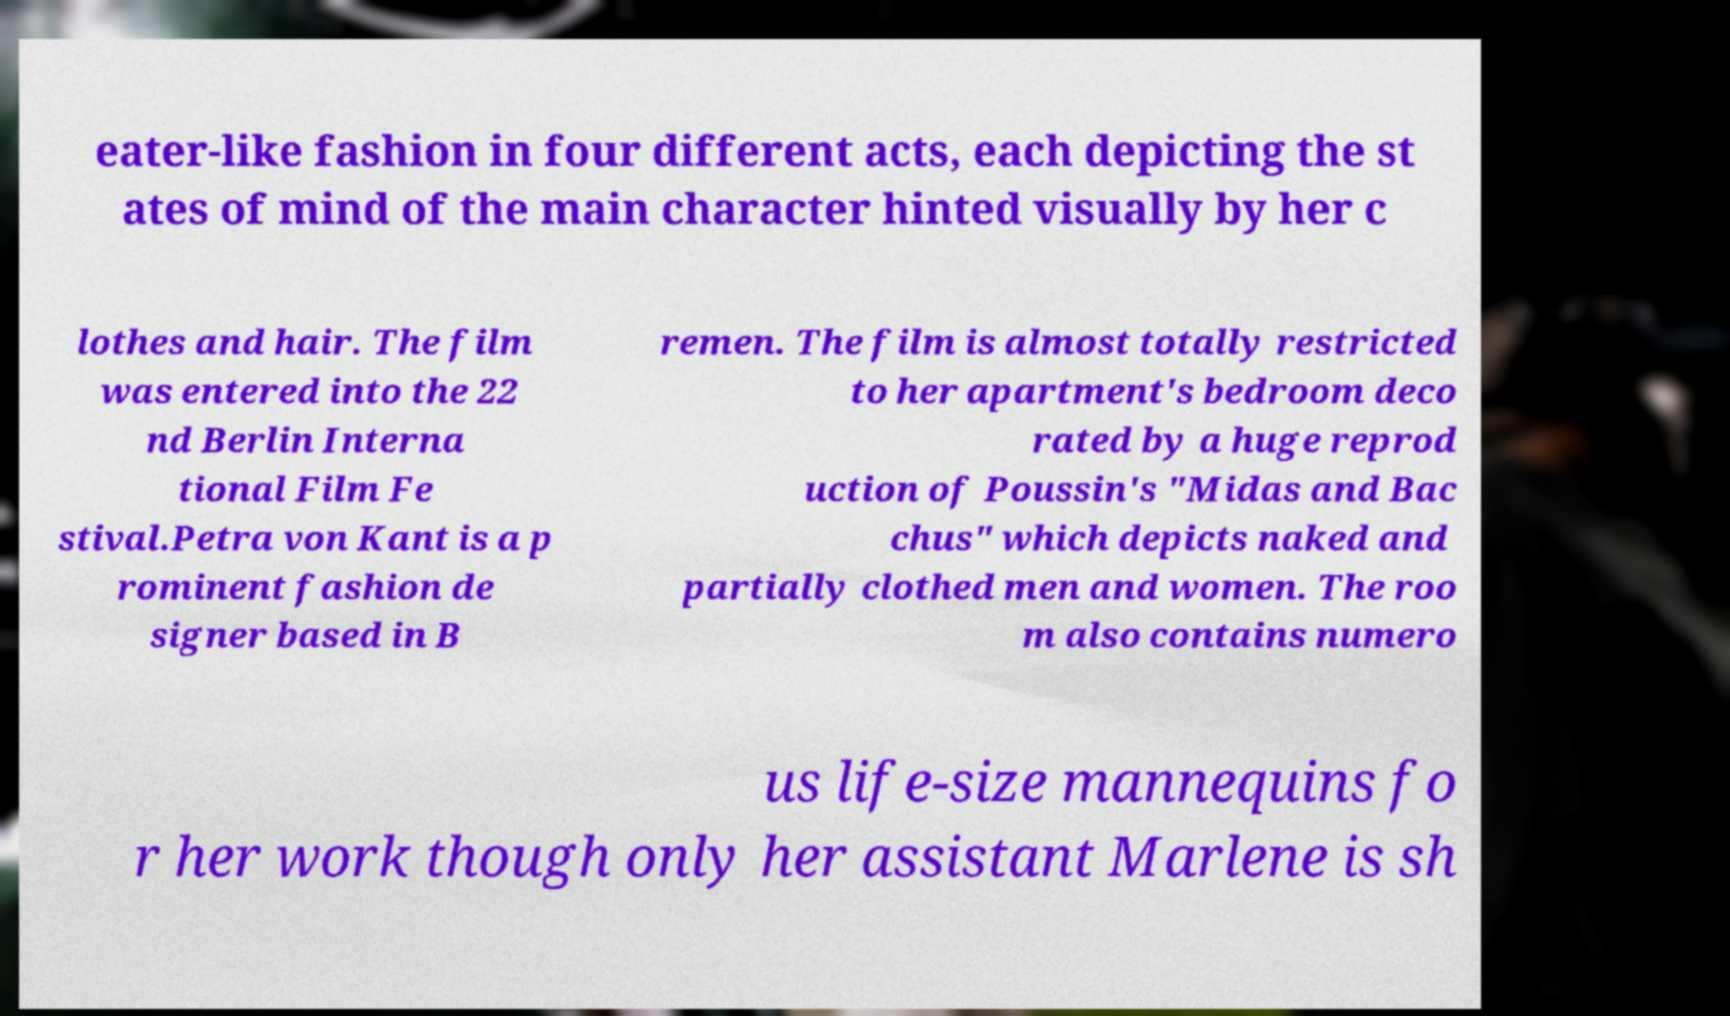What messages or text are displayed in this image? I need them in a readable, typed format. eater-like fashion in four different acts, each depicting the st ates of mind of the main character hinted visually by her c lothes and hair. The film was entered into the 22 nd Berlin Interna tional Film Fe stival.Petra von Kant is a p rominent fashion de signer based in B remen. The film is almost totally restricted to her apartment's bedroom deco rated by a huge reprod uction of Poussin's "Midas and Bac chus" which depicts naked and partially clothed men and women. The roo m also contains numero us life-size mannequins fo r her work though only her assistant Marlene is sh 